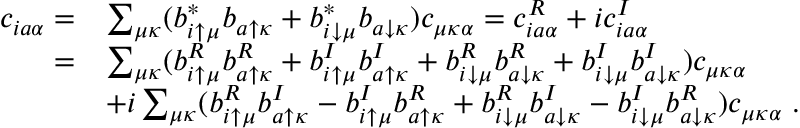<formula> <loc_0><loc_0><loc_500><loc_500>\begin{array} { r l } { c _ { i a \alpha } = } & { \sum _ { \mu \kappa } ( b _ { i \uparrow \mu } ^ { * } b _ { a \uparrow \kappa } + b _ { i \downarrow \mu } ^ { * } b _ { a \downarrow \kappa } ) c _ { \mu \kappa \alpha } = c _ { i a \alpha } ^ { R } + i c _ { i a \alpha } ^ { I } } \\ { = } & { \sum _ { \mu \kappa } ( b _ { i \uparrow \mu } ^ { R } b _ { a \uparrow \kappa } ^ { R } + b _ { i \uparrow \mu } ^ { I } b _ { a \uparrow \kappa } ^ { I } + b _ { i \downarrow \mu } ^ { R } b _ { a \downarrow \kappa } ^ { R } + b _ { i \downarrow \mu } ^ { I } b _ { a \downarrow \kappa } ^ { I } ) c _ { \mu \kappa \alpha } } \\ & { + i \sum _ { \mu \kappa } ( b _ { i \uparrow \mu } ^ { R } b _ { a \uparrow \kappa } ^ { I } - b _ { i \uparrow \mu } ^ { I } b _ { a \uparrow \kappa } ^ { R } + b _ { i \downarrow \mu } ^ { R } b _ { a \downarrow \kappa } ^ { I } - b _ { i \downarrow \mu } ^ { I } b _ { a \downarrow \kappa } ^ { R } ) c _ { \mu \kappa \alpha } \, . } \end{array}</formula> 